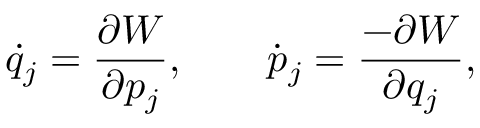<formula> <loc_0><loc_0><loc_500><loc_500>\dot { q } _ { j } = \frac { \partial W } { \partial p _ { j } } , \quad \dot { p } _ { j } = \frac { - \partial W } { \partial q _ { j } } ,</formula> 